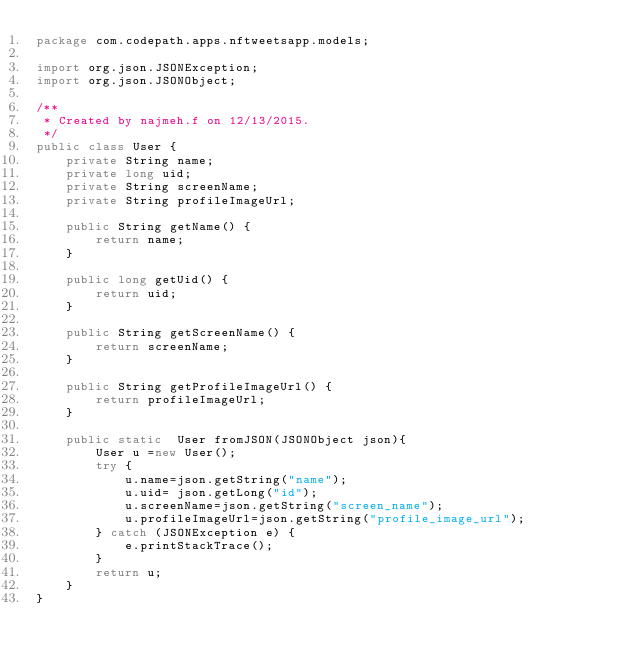Convert code to text. <code><loc_0><loc_0><loc_500><loc_500><_Java_>package com.codepath.apps.nftweetsapp.models;

import org.json.JSONException;
import org.json.JSONObject;

/**
 * Created by najmeh.f on 12/13/2015.
 */
public class User {
    private String name;
    private long uid;
    private String screenName;
    private String profileImageUrl;

    public String getName() {
        return name;
    }

    public long getUid() {
        return uid;
    }

    public String getScreenName() {
        return screenName;
    }

    public String getProfileImageUrl() {
        return profileImageUrl;
    }

    public static  User fromJSON(JSONObject json){
        User u =new User();
        try {
            u.name=json.getString("name");
            u.uid= json.getLong("id");
            u.screenName=json.getString("screen_name");
            u.profileImageUrl=json.getString("profile_image_url");
        } catch (JSONException e) {
            e.printStackTrace();
        }
        return u;
    }
}
</code> 